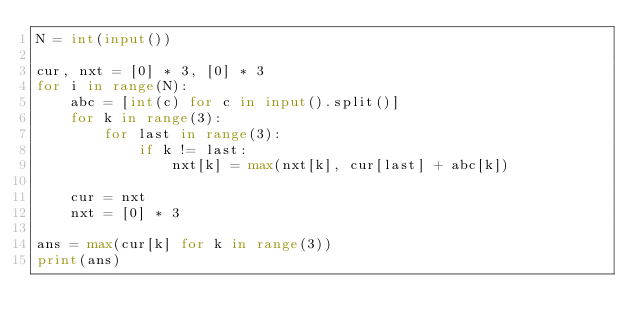Convert code to text. <code><loc_0><loc_0><loc_500><loc_500><_Python_>N = int(input())

cur, nxt = [0] * 3, [0] * 3
for i in range(N):
    abc = [int(c) for c in input().split()]
    for k in range(3):
        for last in range(3):
            if k != last:
                nxt[k] = max(nxt[k], cur[last] + abc[k])

    cur = nxt
    nxt = [0] * 3

ans = max(cur[k] for k in range(3))
print(ans)
</code> 